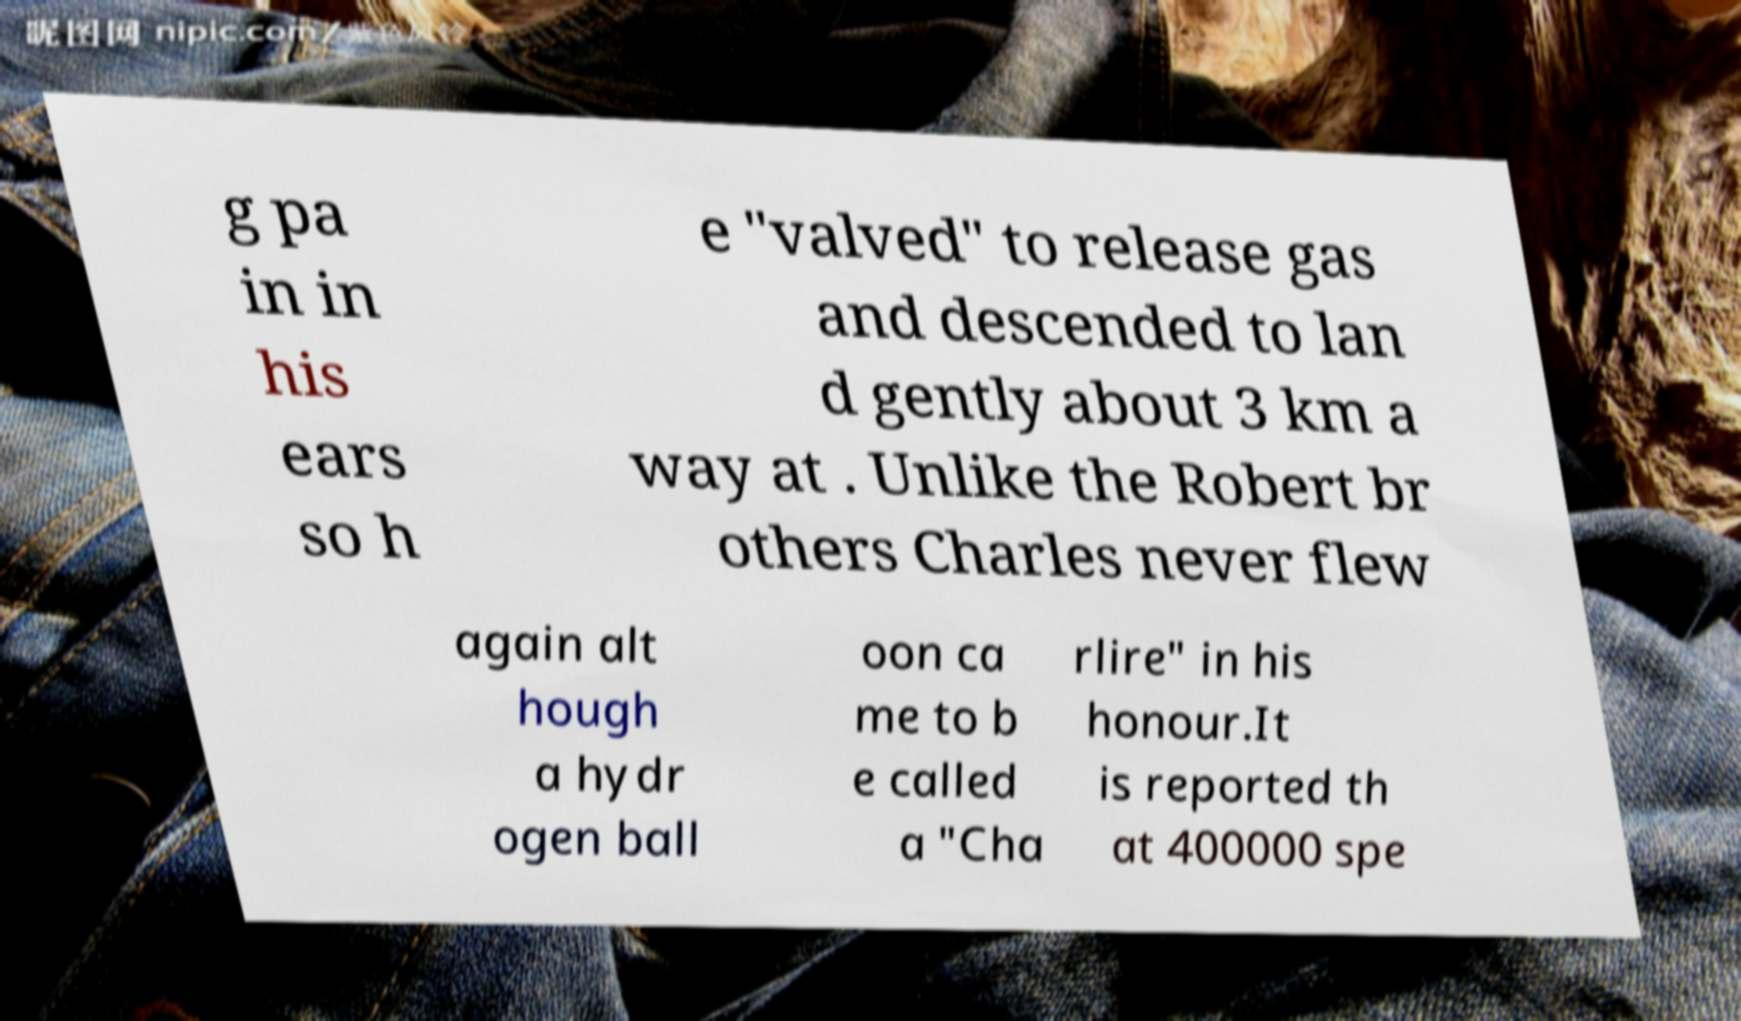Please read and relay the text visible in this image. What does it say? g pa in in his ears so h e "valved" to release gas and descended to lan d gently about 3 km a way at . Unlike the Robert br others Charles never flew again alt hough a hydr ogen ball oon ca me to b e called a "Cha rlire" in his honour.It is reported th at 400000 spe 